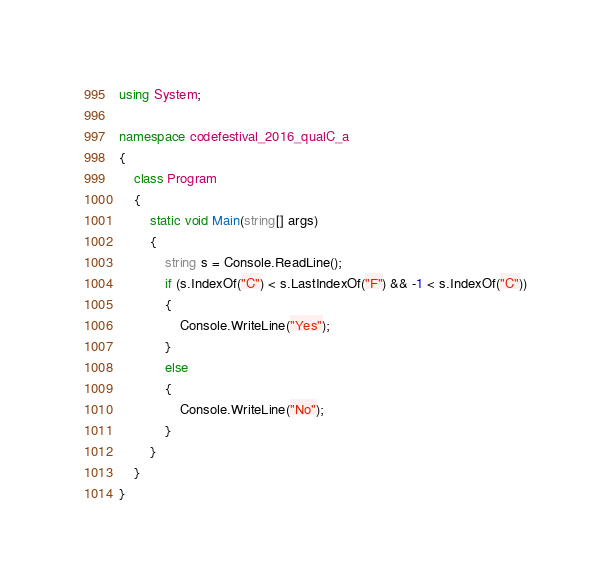<code> <loc_0><loc_0><loc_500><loc_500><_C#_>using System;

namespace codefestival_2016_qualC_a
{
    class Program
    {
        static void Main(string[] args)
        {
            string s = Console.ReadLine();
            if (s.IndexOf("C") < s.LastIndexOf("F") && -1 < s.IndexOf("C"))
            {
                Console.WriteLine("Yes");
            }
            else
            {
                Console.WriteLine("No");
            }
        }
    }
}</code> 